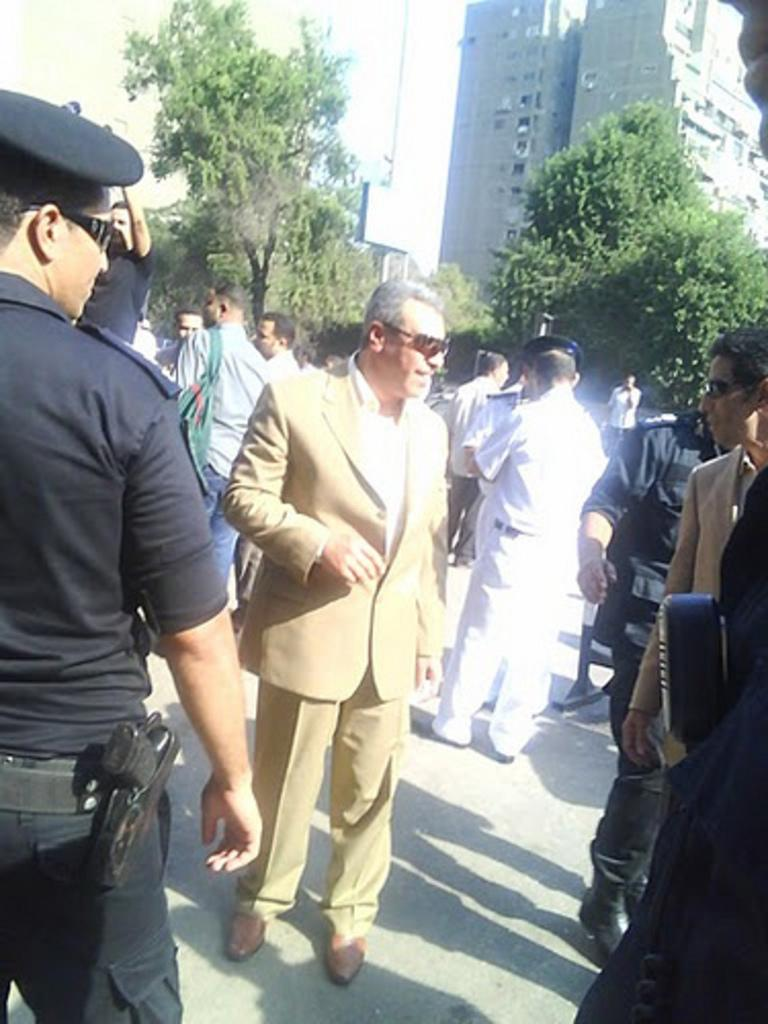What is happening at the bottom of the image? There is a road at the bottom of the image, and many people are standing on it. What can be seen in the background of the image? There are trees and buildings in the background of the image. What is visible at the top of the image? The sky is visible at the top of the image. How many quinces are hanging from the trees in the image? There are no quinces present in the image; it only features trees and buildings in the background. What type of things are the people wearing around their necks in the image? There is no information about what the people might be wearing around their necks in the image. 